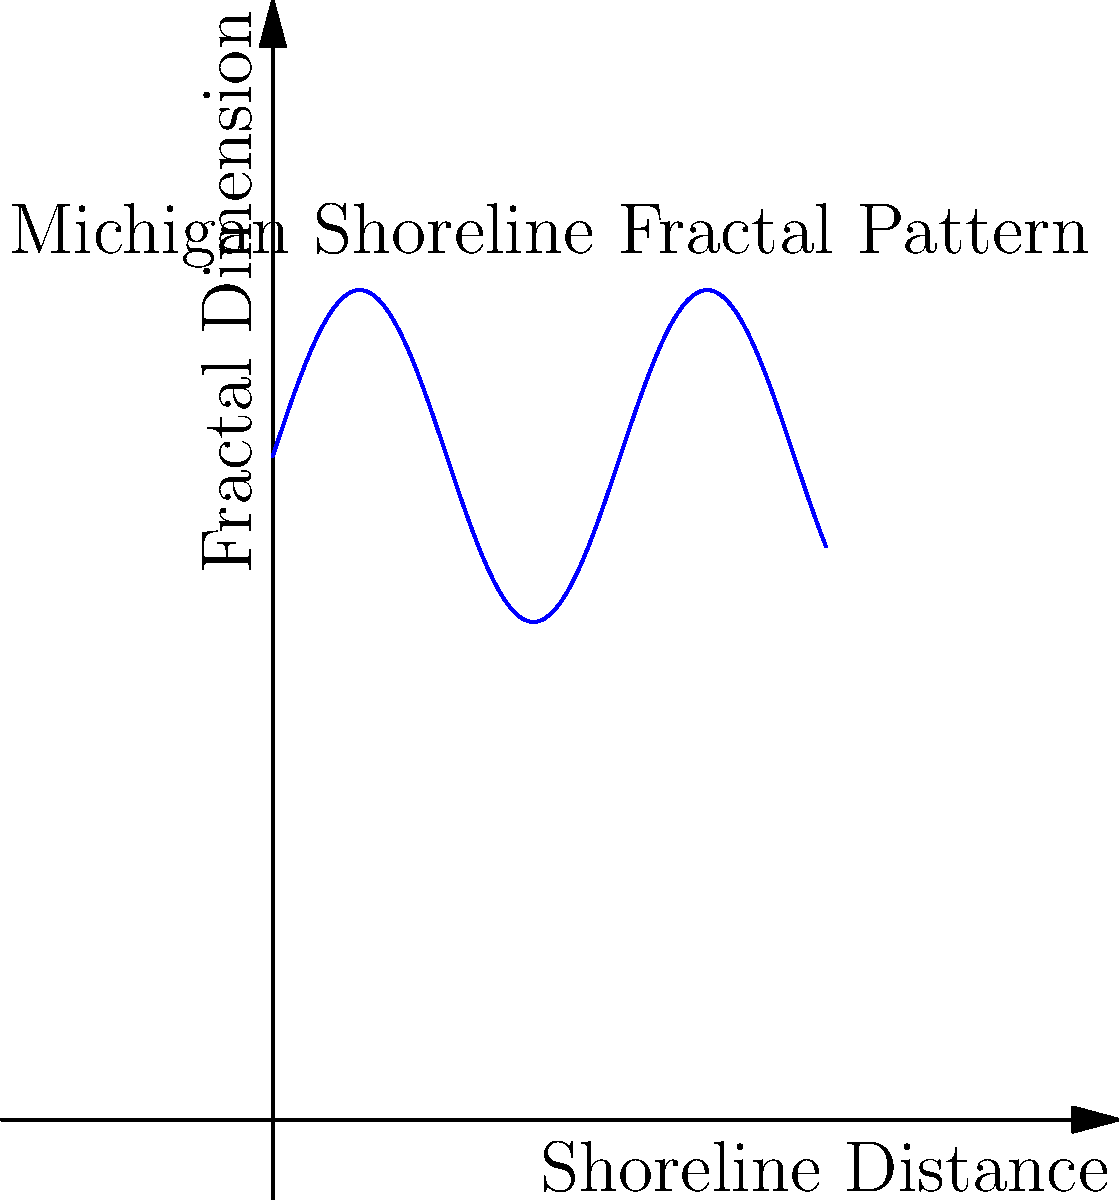As a new resident of Michigan with a keen interest in photography, you've noticed the intricate patterns along the Great Lakes shoreline. If the fractal dimension of the shoreline varies between 1.2 and 1.5 as shown in the graph, what would be the approximate average fractal dimension of Michigan's Great Lakes shoreline? To solve this problem, we need to follow these steps:

1. Observe the graph: The blue line represents the fractal dimension of Michigan's shoreline over a normalized distance.

2. Identify the range: The fractal dimension oscillates between approximately 1.2 and 1.5.

3. Calculate the average:
   a. Minimum value: 1.2
   b. Maximum value: 1.5
   c. Average = $\frac{\text{Minimum} + \text{Maximum}}{2}$
   d. Average = $\frac{1.2 + 1.5}{2} = \frac{2.7}{2} = 1.35$

4. Interpret the result: The average fractal dimension of 1.35 indicates that Michigan's Great Lakes shoreline is more complex than a smooth line (which would have a fractal dimension of 1) but less complex than a space-filling curve (which would have a fractal dimension of 2).

5. Photography relevance: Understanding the fractal dimension can help in composing landscape photographs that capture the intricate details of the shoreline, potentially leading to more visually interesting images.
Answer: 1.35 